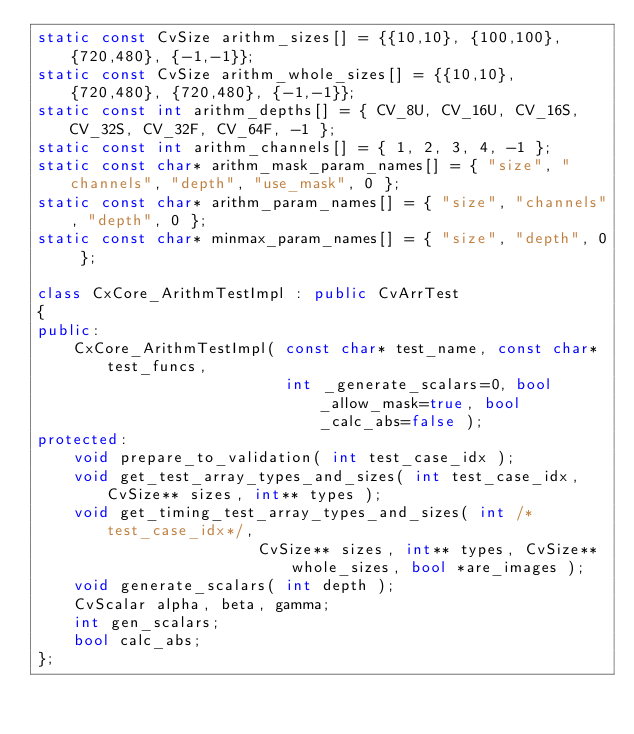Convert code to text. <code><loc_0><loc_0><loc_500><loc_500><_C++_>static const CvSize arithm_sizes[] = {{10,10}, {100,100}, {720,480}, {-1,-1}};
static const CvSize arithm_whole_sizes[] = {{10,10}, {720,480}, {720,480}, {-1,-1}};
static const int arithm_depths[] = { CV_8U, CV_16U, CV_16S, CV_32S, CV_32F, CV_64F, -1 };
static const int arithm_channels[] = { 1, 2, 3, 4, -1 };
static const char* arithm_mask_param_names[] = { "size", "channels", "depth", "use_mask", 0 };
static const char* arithm_param_names[] = { "size", "channels", "depth", 0 };
static const char* minmax_param_names[] = { "size", "depth", 0 };

class CxCore_ArithmTestImpl : public CvArrTest
{
public:
    CxCore_ArithmTestImpl( const char* test_name, const char* test_funcs,
                           int _generate_scalars=0, bool _allow_mask=true, bool _calc_abs=false );
protected:
    void prepare_to_validation( int test_case_idx );
    void get_test_array_types_and_sizes( int test_case_idx, CvSize** sizes, int** types );
    void get_timing_test_array_types_and_sizes( int /*test_case_idx*/,
                        CvSize** sizes, int** types, CvSize** whole_sizes, bool *are_images );
    void generate_scalars( int depth );
    CvScalar alpha, beta, gamma;
    int gen_scalars;
    bool calc_abs;
};

</code> 